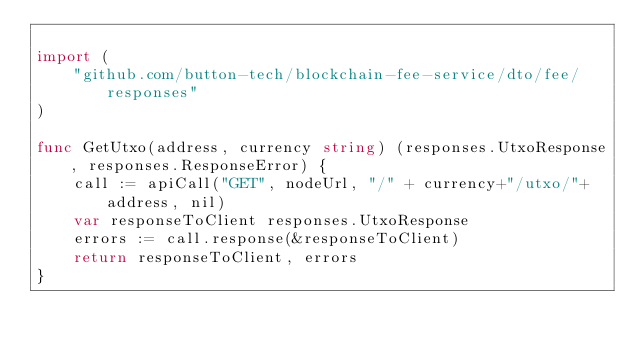Convert code to text. <code><loc_0><loc_0><loc_500><loc_500><_Go_>
import (
	"github.com/button-tech/blockchain-fee-service/dto/fee/responses"
)

func GetUtxo(address, currency string) (responses.UtxoResponse, responses.ResponseError) {
	call := apiCall("GET", nodeUrl, "/" + currency+"/utxo/"+address, nil)
	var responseToClient responses.UtxoResponse
	errors := call.response(&responseToClient)
	return responseToClient, errors
}
</code> 